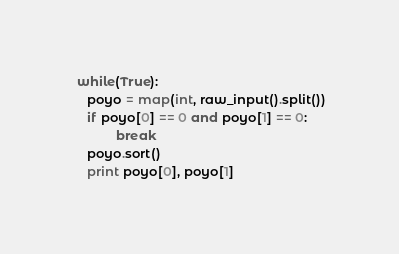Convert code to text. <code><loc_0><loc_0><loc_500><loc_500><_Python_> while(True):
    poyo = map(int, raw_input().split())
    if poyo[0] == 0 and poyo[1] == 0:
            break
    poyo.sort()
    print poyo[0], poyo[1]</code> 